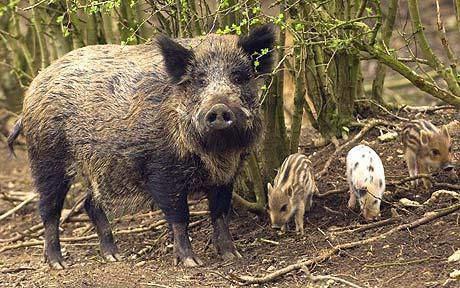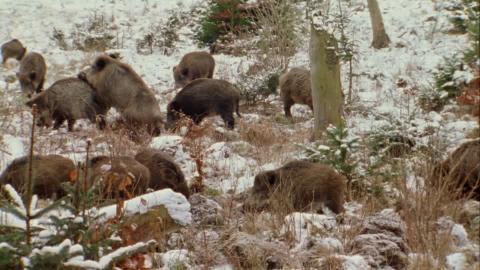The first image is the image on the left, the second image is the image on the right. For the images displayed, is the sentence "a warthog is standing facing the camera with piglets near her" factually correct? Answer yes or no. Yes. The first image is the image on the left, the second image is the image on the right. Assess this claim about the two images: "There are some piglets in the left image.". Correct or not? Answer yes or no. Yes. 